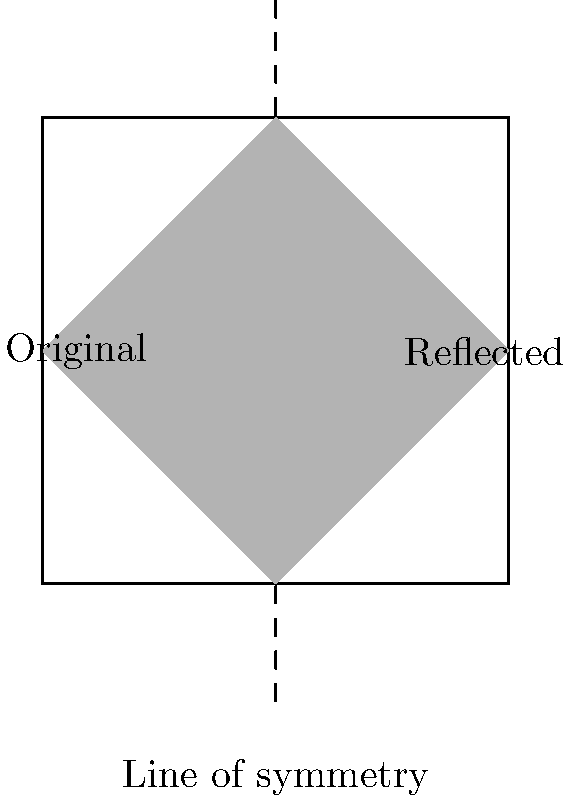A graffiti artist has created a stylized letter "O" on a wall, as shown in the left half of the square. If this letter is reflected across the vertical line of symmetry, what will be the shape of the reflected letter? To solve this problem, let's follow these steps:

1. Identify the original shape: The original letter "O" is a rhombus-like shape with its corners touching the middle of each side of the left half of the square.

2. Locate the line of symmetry: The vertical dashed line in the middle of the square is the line of symmetry.

3. Understand reflection: Reflection across a line of symmetry means that each point of the original shape is "flipped" over the line, maintaining the same distance from the line.

4. Analyze the reflection:
   - The point touching the left side of the square will be reflected to touch the right side.
   - The point touching the top of the square will remain at the top, but on the right half.
   - The point touching the bottom of the square will remain at the bottom, but on the right half.
   - The point touching the line of symmetry at the middle right of the original shape will touch the line of symmetry at the middle left of the reflected shape.

5. Visualize the result: The reflected shape will be identical to the original shape, but flipped horizontally. It will form another rhombus-like shape in the right half of the square, with its corners touching the middle of each side of the right half.

6. Compare with the given image: The reflected shape shown in the right half of the square matches our analysis.
Answer: A rhombus-like shape in the right half of the square, mirroring the original. 